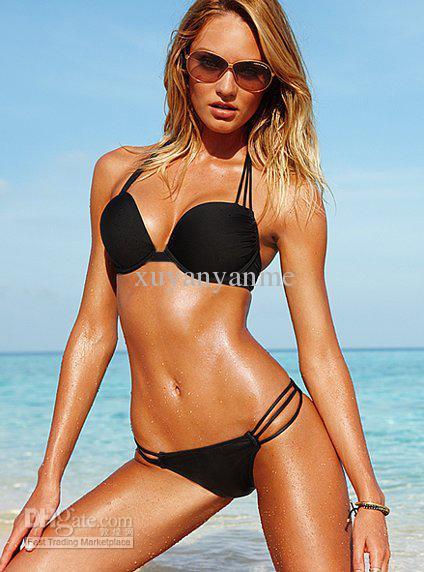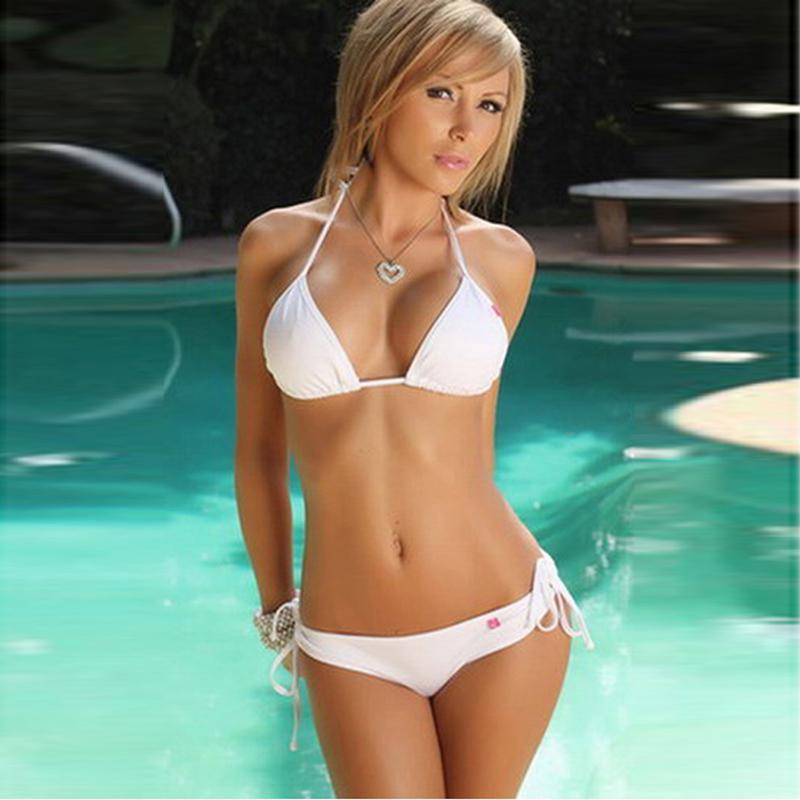The first image is the image on the left, the second image is the image on the right. Considering the images on both sides, is "The left and right image contains the same number of women in bikinis with at least one in all white." valid? Answer yes or no. Yes. 